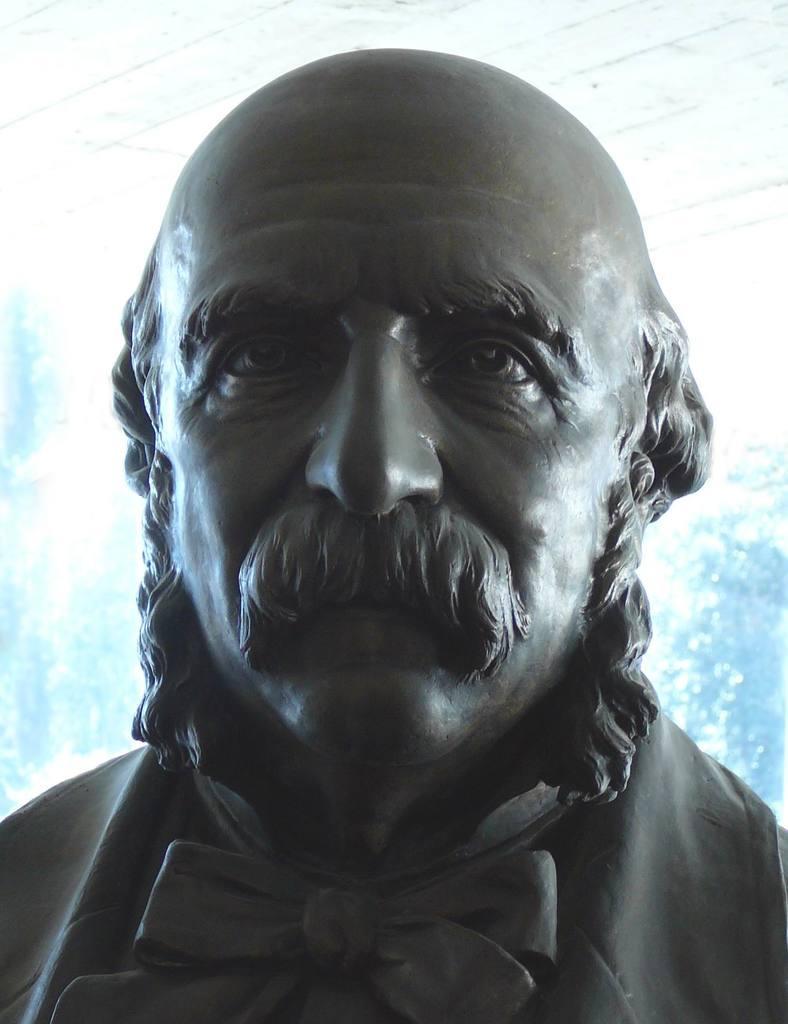Describe this image in one or two sentences. In this image I can see a sculpture of a man in the front. 